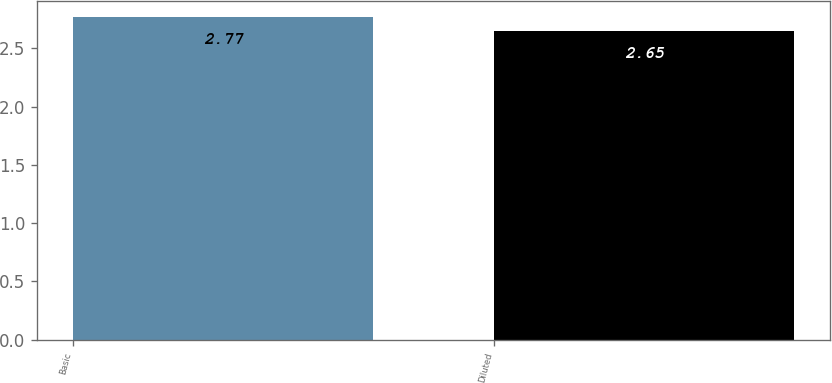Convert chart to OTSL. <chart><loc_0><loc_0><loc_500><loc_500><bar_chart><fcel>Basic<fcel>Diluted<nl><fcel>2.77<fcel>2.65<nl></chart> 